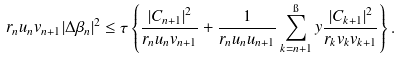Convert formula to latex. <formula><loc_0><loc_0><loc_500><loc_500>r _ { n } u _ { n } v _ { n + 1 } | \Delta \beta _ { n } | ^ { 2 } \leq \tau \left \{ \frac { | C _ { n + 1 } | ^ { 2 } } { r _ { n } u _ { n } v _ { n + 1 } } + \frac { 1 } { r _ { n } u _ { n } u _ { n + 1 } } \sum _ { k = n + 1 } ^ { \i } y \frac { | C _ { k + 1 } | ^ { 2 } } { r _ { k } v _ { k } v _ { k + 1 } } \right \} .</formula> 